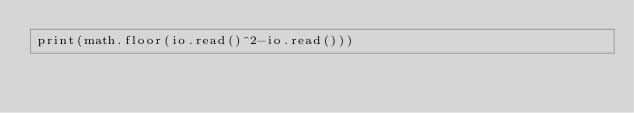Convert code to text. <code><loc_0><loc_0><loc_500><loc_500><_Lua_>print(math.floor(io.read()^2-io.read()))</code> 